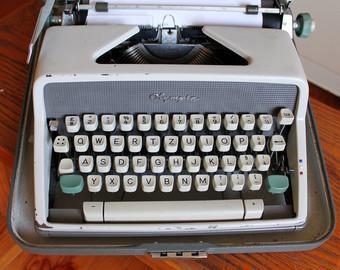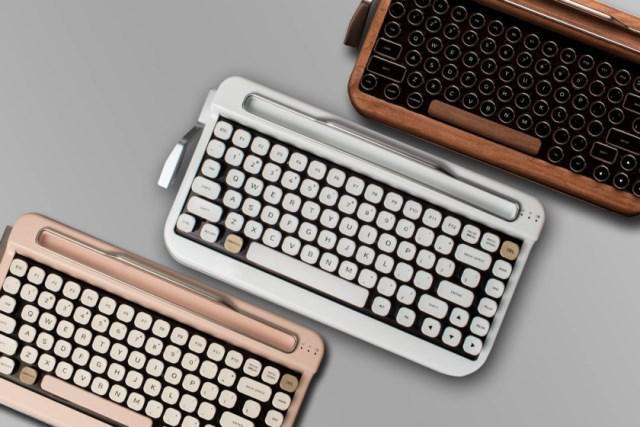The first image is the image on the left, the second image is the image on the right. Evaluate the accuracy of this statement regarding the images: "In one image, an old-fashioned typewriter is shown with at least some of the keys colored.". Is it true? Answer yes or no. Yes. The first image is the image on the left, the second image is the image on the right. Analyze the images presented: Is the assertion "Several keyboards appear in at least one of the images." valid? Answer yes or no. Yes. 